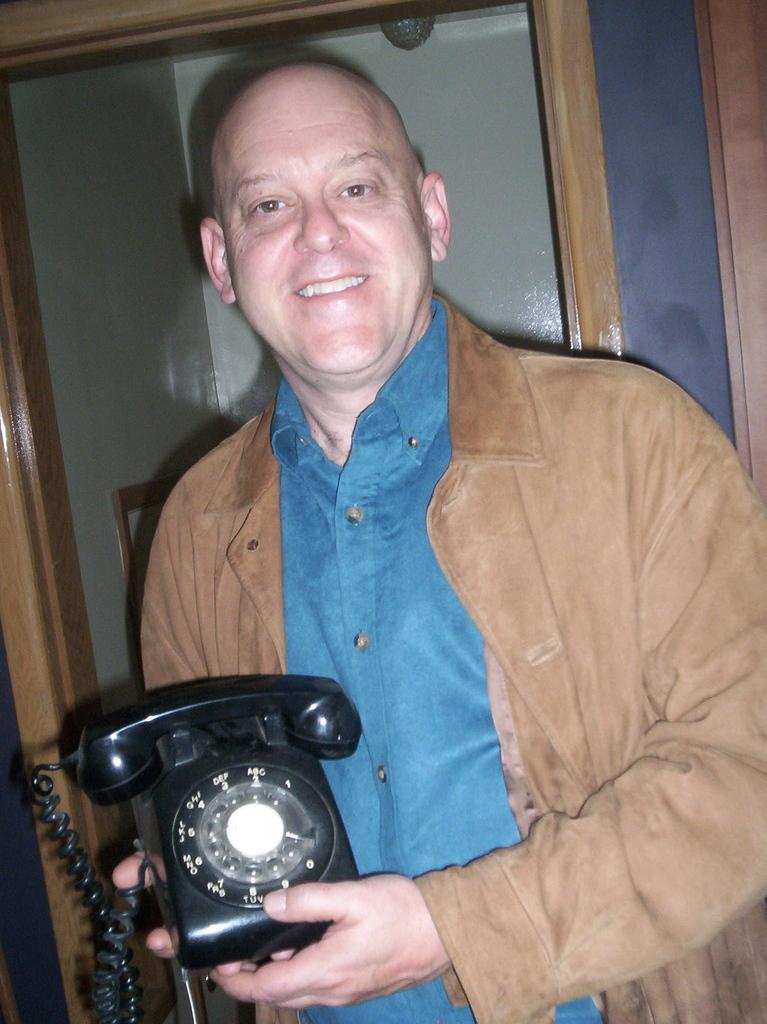What is the man in the image doing? The man is holding a telephone and watching something. How is the man feeling in the image? The man is smiling, which suggests he is feeling happy or content. What can be seen in the background of the image? There is a wall, a frame, and wooden objects in the background of the image. Can you see any crayons being used by the man in the image? There are no crayons present in the image. Is the man cooking anything in the image? There is no indication that the man is cooking in the image. 